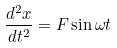Convert formula to latex. <formula><loc_0><loc_0><loc_500><loc_500>\frac { d ^ { 2 } x } { d t ^ { 2 } } = F \sin \omega t</formula> 